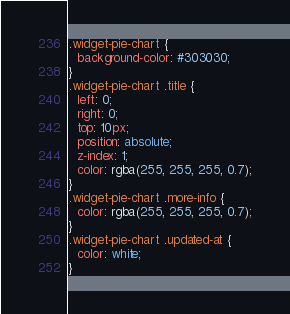<code> <loc_0><loc_0><loc_500><loc_500><_CSS_>.widget-pie-chart {
  background-color: #303030;
}
.widget-pie-chart .title {
  left: 0;
  right: 0;
  top: 10px;
  position: absolute;
  z-index: 1;
  color: rgba(255, 255, 255, 0.7);
}
.widget-pie-chart .more-info {
  color: rgba(255, 255, 255, 0.7);
}
.widget-pie-chart .updated-at {
  color: white;
}
</code> 